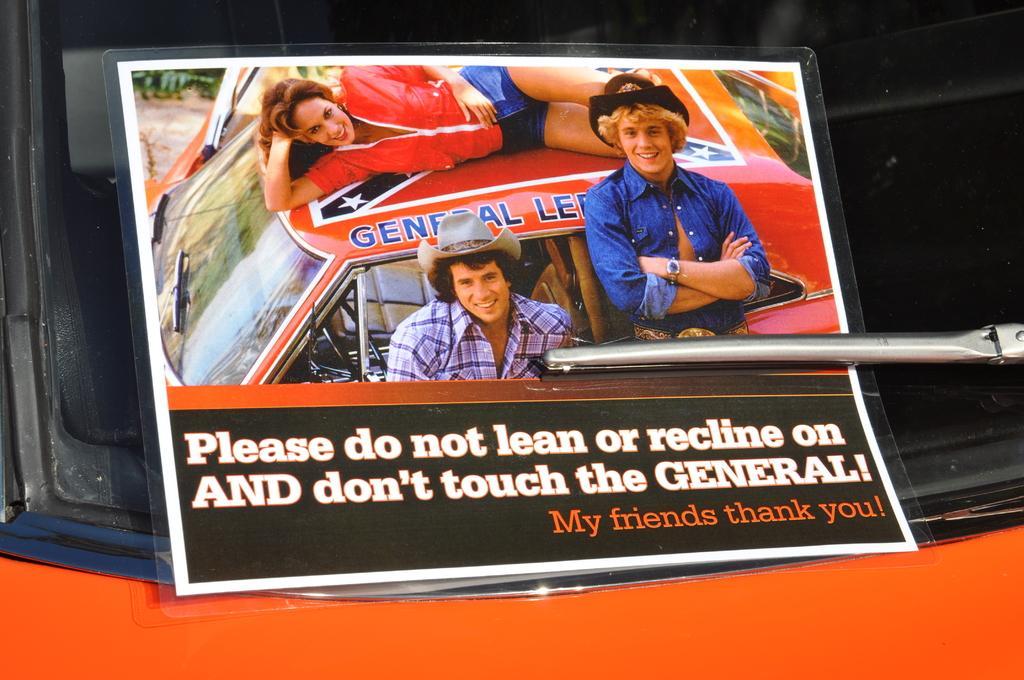In one or two sentences, can you explain what this image depicts? This is a photo frame which is placed on the glass mirror of a car and the people in the photo frame are smiling. 